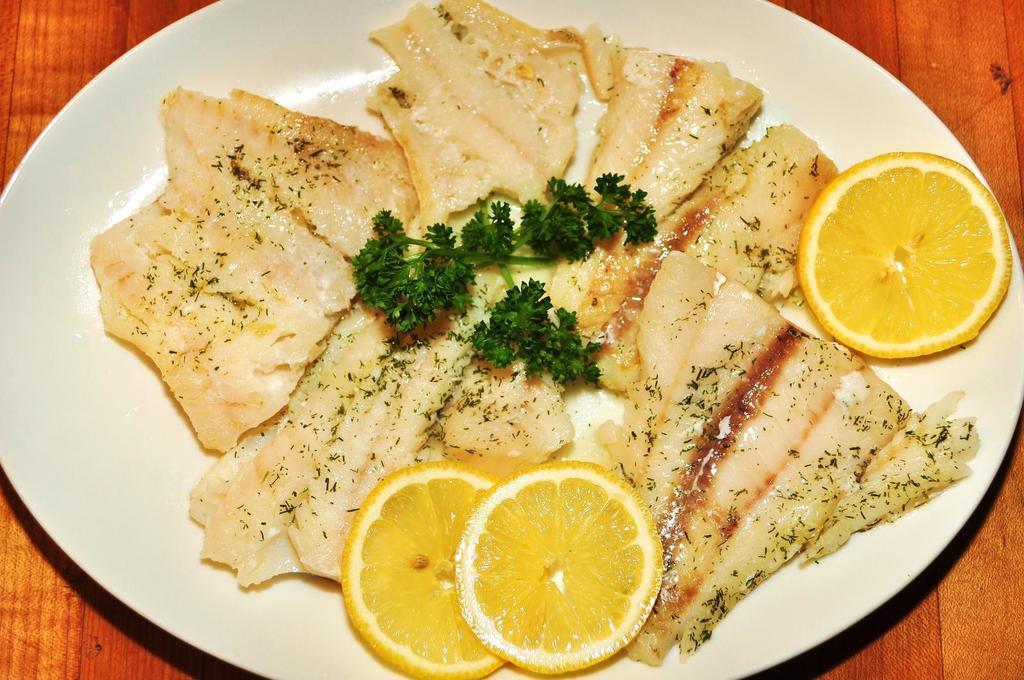Please provide a concise description of this image. In this picture I can see a food item on the plate, on the wooden board. 